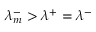Convert formula to latex. <formula><loc_0><loc_0><loc_500><loc_500>\lambda _ { m } ^ { - } > \lambda ^ { + } = \lambda ^ { - }</formula> 